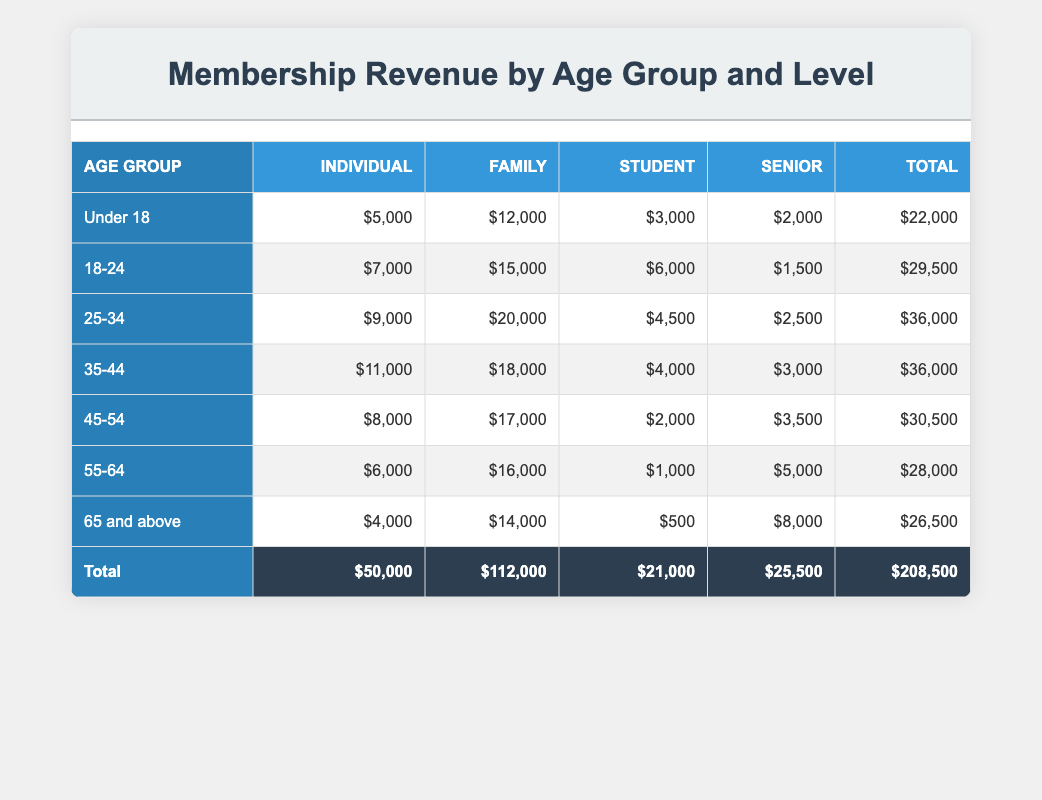What is the total revenue from the Family membership level? To find the total revenue from the Family membership level, we sum all the values in the Family column: 12000 + 15000 + 20000 + 18000 + 17000 + 16000 + 14000 = 112000
Answer: 112000 Which age group has the highest revenue from Individual memberships? The Individual membership revenue is highest for the 35-44 age group, which has 11000.
Answer: 11000 Is the revenue from Student memberships greater than the revenue from Senior memberships for the age group 45-54? For the age group 45-54, the Student revenue is 2000 while the Senior revenue is 3500. Since 2000 < 3500, the statement is false.
Answer: No What is the average revenue from Individual memberships across all age groups? The total revenue from Individual memberships is 5000 + 7000 + 9000 + 11000 + 8000 + 6000 + 4000 = 50000. Since there are 7 age groups, the average is 50000 / 7 = approximately 7142.86.
Answer: 7142.86 Which age group contributes the least revenue in total? To find the lowest total revenue, we sum the revenues for each age group: Under 18 = 22000, 18-24 = 29500, 25-34 = 36000, 35-44 = 36000, 45-54 = 30500, 55-64 = 28000, 65 and above = 26500. The age group '65 and above' has the least at 26500.
Answer: 26500 What is the difference in revenue between Family and Senior memberships for the age group 55-64? For the age group 55-64, the Family membership revenue is 16000 and Senior is 5000. The difference is 16000 - 5000 = 11000.
Answer: 11000 Is the revenue from the Family memberships among the ages 25-34 and 35-44 the same? The Family revenue for age group 25-34 is 20000, and for the 35-44 age group, it is 18000. Since 20000 is not equal to 18000, the statement is false.
Answer: No What percentage of the total revenue do Individual memberships represent? The total revenue is 208500, and Individual membership revenue is 50000. The percentage is (50000 / 208500) * 100 ≈ 24%.
Answer: 24% What is the total revenue for ages 65 and above compared to all other age groups combined? The revenue for ages 65 and above is 26500, and for all other groups, it is 208500 - 26500 = 181000. Therefore, 26500 is less than 181000.
Answer: Yes 